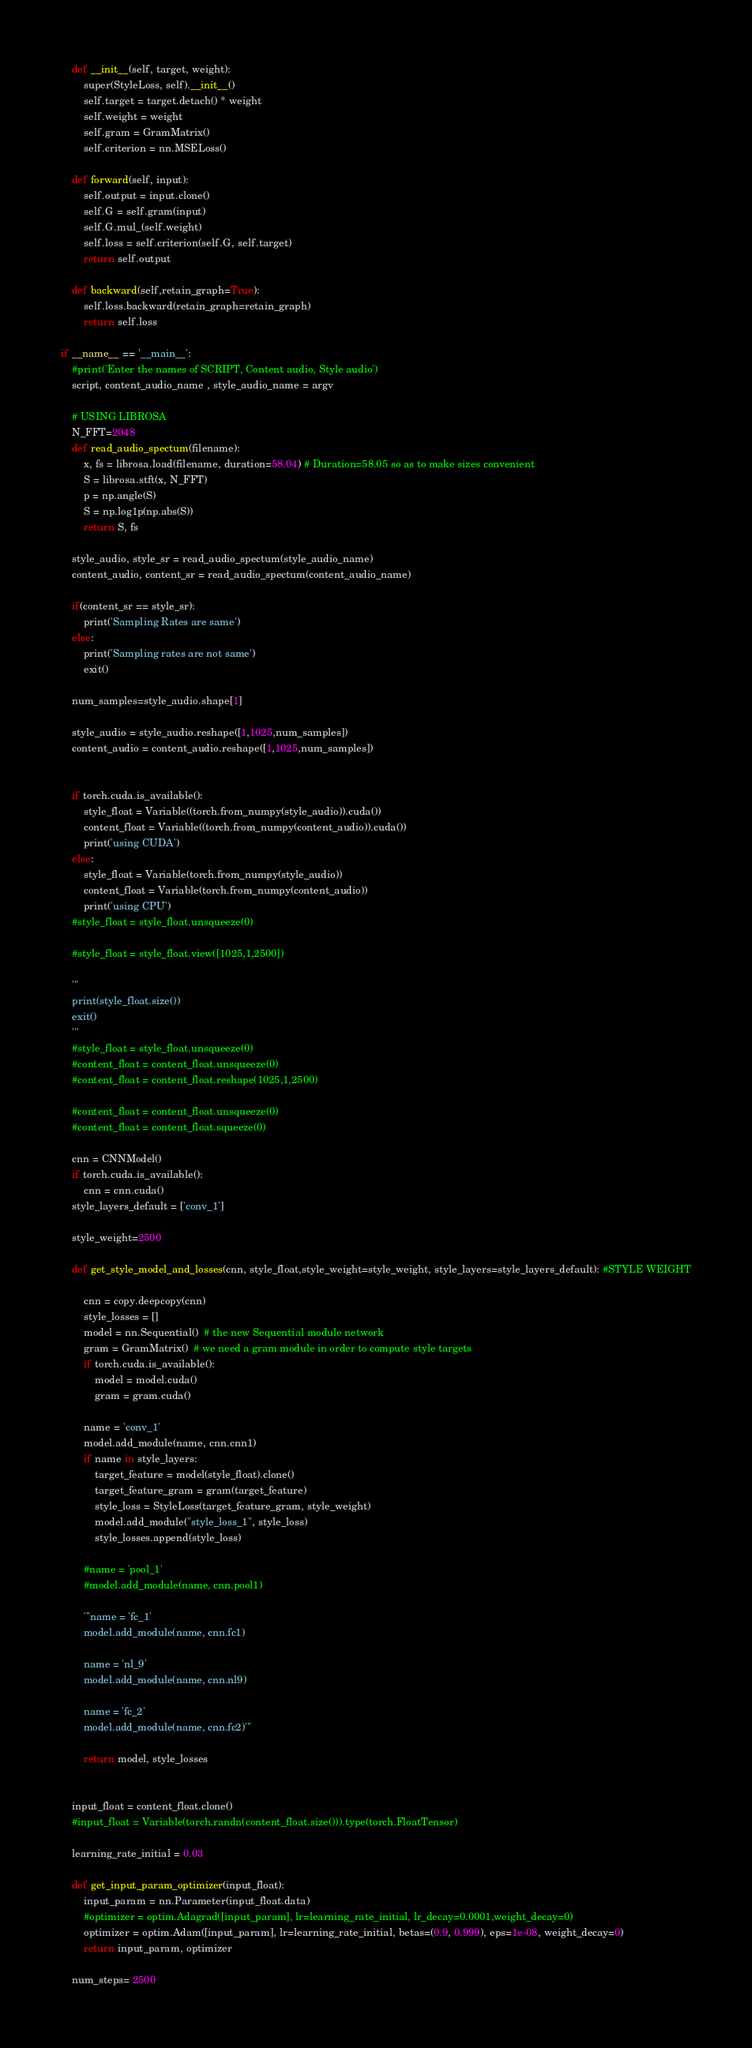<code> <loc_0><loc_0><loc_500><loc_500><_Python_>
	def __init__(self, target, weight):
		super(StyleLoss, self).__init__()
		self.target = target.detach() * weight
		self.weight = weight
		self.gram = GramMatrix()
		self.criterion = nn.MSELoss()

	def forward(self, input):
		self.output = input.clone()
		self.G = self.gram(input)
		self.G.mul_(self.weight)
		self.loss = self.criterion(self.G, self.target)
		return self.output

	def backward(self,retain_graph=True):
		self.loss.backward(retain_graph=retain_graph)
		return self.loss

if __name__ == '__main__':
	#print('Enter the names of SCRIPT, Content audio, Style audio')
	script, content_audio_name , style_audio_name = argv

	# USING LIBROSA
	N_FFT=2048
	def read_audio_spectum(filename):
		x, fs = librosa.load(filename, duration=58.04) # Duration=58.05 so as to make sizes convenient
		S = librosa.stft(x, N_FFT)
		p = np.angle(S)
		S = np.log1p(np.abs(S))  
		return S, fs

	style_audio, style_sr = read_audio_spectum(style_audio_name)
	content_audio, content_sr = read_audio_spectum(content_audio_name)

	if(content_sr == style_sr):
		print('Sampling Rates are same')
	else:
		print('Sampling rates are not same')
		exit()

	num_samples=style_audio.shape[1]	
		
	style_audio = style_audio.reshape([1,1025,num_samples])
	content_audio = content_audio.reshape([1,1025,num_samples])


	if torch.cuda.is_available():
		style_float = Variable((torch.from_numpy(style_audio)).cuda())
		content_float = Variable((torch.from_numpy(content_audio)).cuda())	
		print('using CUDA')
	else:
		style_float = Variable(torch.from_numpy(style_audio))
		content_float = Variable(torch.from_numpy(content_audio))
		print('using CPU')
	#style_float = style_float.unsqueeze(0)
	
	#style_float = style_float.view([1025,1,2500])
	
	'''
	print(style_float.size())
	exit()
	'''
	#style_float = style_float.unsqueeze(0)
	#content_float = content_float.unsqueeze(0)
	#content_float = content_float.reshape(1025,1,2500)
	
	#content_float = content_float.unsqueeze(0)
	#content_float = content_float.squeeze(0)

	cnn = CNNModel()
	if torch.cuda.is_available():
		cnn = cnn.cuda()
	style_layers_default = ['conv_1']

	style_weight=2500

	def get_style_model_and_losses(cnn, style_float,style_weight=style_weight, style_layers=style_layers_default): #STYLE WEIGHT
		
		cnn = copy.deepcopy(cnn)
		style_losses = []
		model = nn.Sequential()  # the new Sequential module network
		gram = GramMatrix()  # we need a gram module in order to compute style targets
		if torch.cuda.is_available():
			model = model.cuda()
			gram = gram.cuda()

		name = 'conv_1'
		model.add_module(name, cnn.cnn1)
		if name in style_layers:
			target_feature = model(style_float).clone()
			target_feature_gram = gram(target_feature)
			style_loss = StyleLoss(target_feature_gram, style_weight)
			model.add_module("style_loss_1", style_loss)
			style_losses.append(style_loss)

		#name = 'pool_1'
		#model.add_module(name, cnn.pool1)

		'''name = 'fc_1'
		model.add_module(name, cnn.fc1)

		name = 'nl_9'
		model.add_module(name, cnn.nl9)

		name = 'fc_2'
		model.add_module(name, cnn.fc2)'''

		return model, style_losses


	input_float = content_float.clone()
	#input_float = Variable(torch.randn(content_float.size())).type(torch.FloatTensor)

	learning_rate_initial = 0.03

	def get_input_param_optimizer(input_float):
		input_param = nn.Parameter(input_float.data)
		#optimizer = optim.Adagrad([input_param], lr=learning_rate_initial, lr_decay=0.0001,weight_decay=0)
		optimizer = optim.Adam([input_param], lr=learning_rate_initial, betas=(0.9, 0.999), eps=1e-08, weight_decay=0)
		return input_param, optimizer

	num_steps= 2500
</code> 